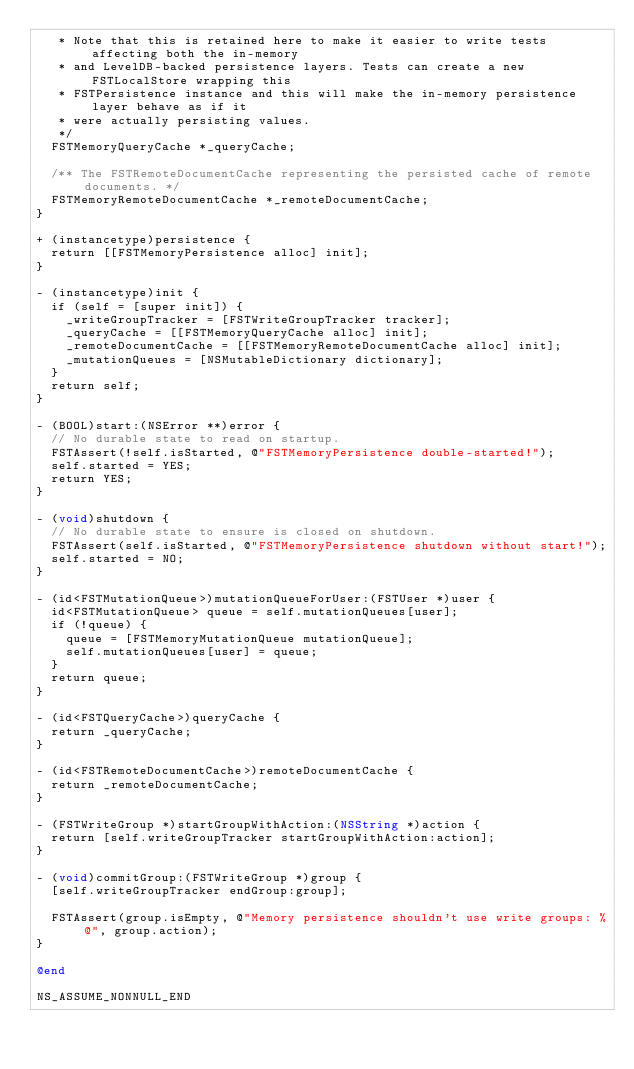Convert code to text. <code><loc_0><loc_0><loc_500><loc_500><_ObjectiveC_>   * Note that this is retained here to make it easier to write tests affecting both the in-memory
   * and LevelDB-backed persistence layers. Tests can create a new FSTLocalStore wrapping this
   * FSTPersistence instance and this will make the in-memory persistence layer behave as if it
   * were actually persisting values.
   */
  FSTMemoryQueryCache *_queryCache;

  /** The FSTRemoteDocumentCache representing the persisted cache of remote documents. */
  FSTMemoryRemoteDocumentCache *_remoteDocumentCache;
}

+ (instancetype)persistence {
  return [[FSTMemoryPersistence alloc] init];
}

- (instancetype)init {
  if (self = [super init]) {
    _writeGroupTracker = [FSTWriteGroupTracker tracker];
    _queryCache = [[FSTMemoryQueryCache alloc] init];
    _remoteDocumentCache = [[FSTMemoryRemoteDocumentCache alloc] init];
    _mutationQueues = [NSMutableDictionary dictionary];
  }
  return self;
}

- (BOOL)start:(NSError **)error {
  // No durable state to read on startup.
  FSTAssert(!self.isStarted, @"FSTMemoryPersistence double-started!");
  self.started = YES;
  return YES;
}

- (void)shutdown {
  // No durable state to ensure is closed on shutdown.
  FSTAssert(self.isStarted, @"FSTMemoryPersistence shutdown without start!");
  self.started = NO;
}

- (id<FSTMutationQueue>)mutationQueueForUser:(FSTUser *)user {
  id<FSTMutationQueue> queue = self.mutationQueues[user];
  if (!queue) {
    queue = [FSTMemoryMutationQueue mutationQueue];
    self.mutationQueues[user] = queue;
  }
  return queue;
}

- (id<FSTQueryCache>)queryCache {
  return _queryCache;
}

- (id<FSTRemoteDocumentCache>)remoteDocumentCache {
  return _remoteDocumentCache;
}

- (FSTWriteGroup *)startGroupWithAction:(NSString *)action {
  return [self.writeGroupTracker startGroupWithAction:action];
}

- (void)commitGroup:(FSTWriteGroup *)group {
  [self.writeGroupTracker endGroup:group];

  FSTAssert(group.isEmpty, @"Memory persistence shouldn't use write groups: %@", group.action);
}

@end

NS_ASSUME_NONNULL_END
</code> 